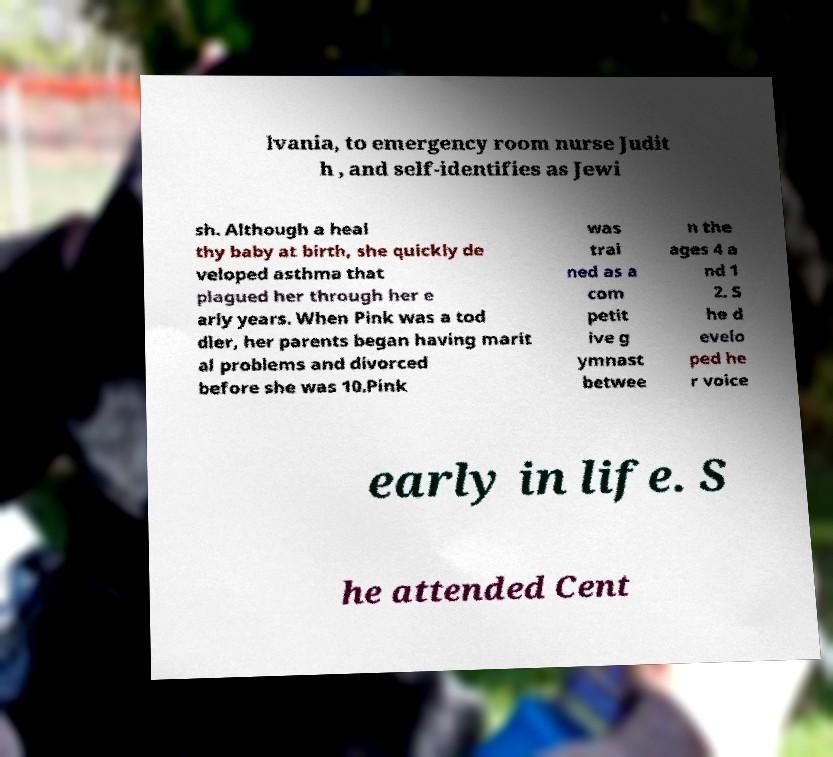I need the written content from this picture converted into text. Can you do that? lvania, to emergency room nurse Judit h , and self-identifies as Jewi sh. Although a heal thy baby at birth, she quickly de veloped asthma that plagued her through her e arly years. When Pink was a tod dler, her parents began having marit al problems and divorced before she was 10.Pink was trai ned as a com petit ive g ymnast betwee n the ages 4 a nd 1 2. S he d evelo ped he r voice early in life. S he attended Cent 